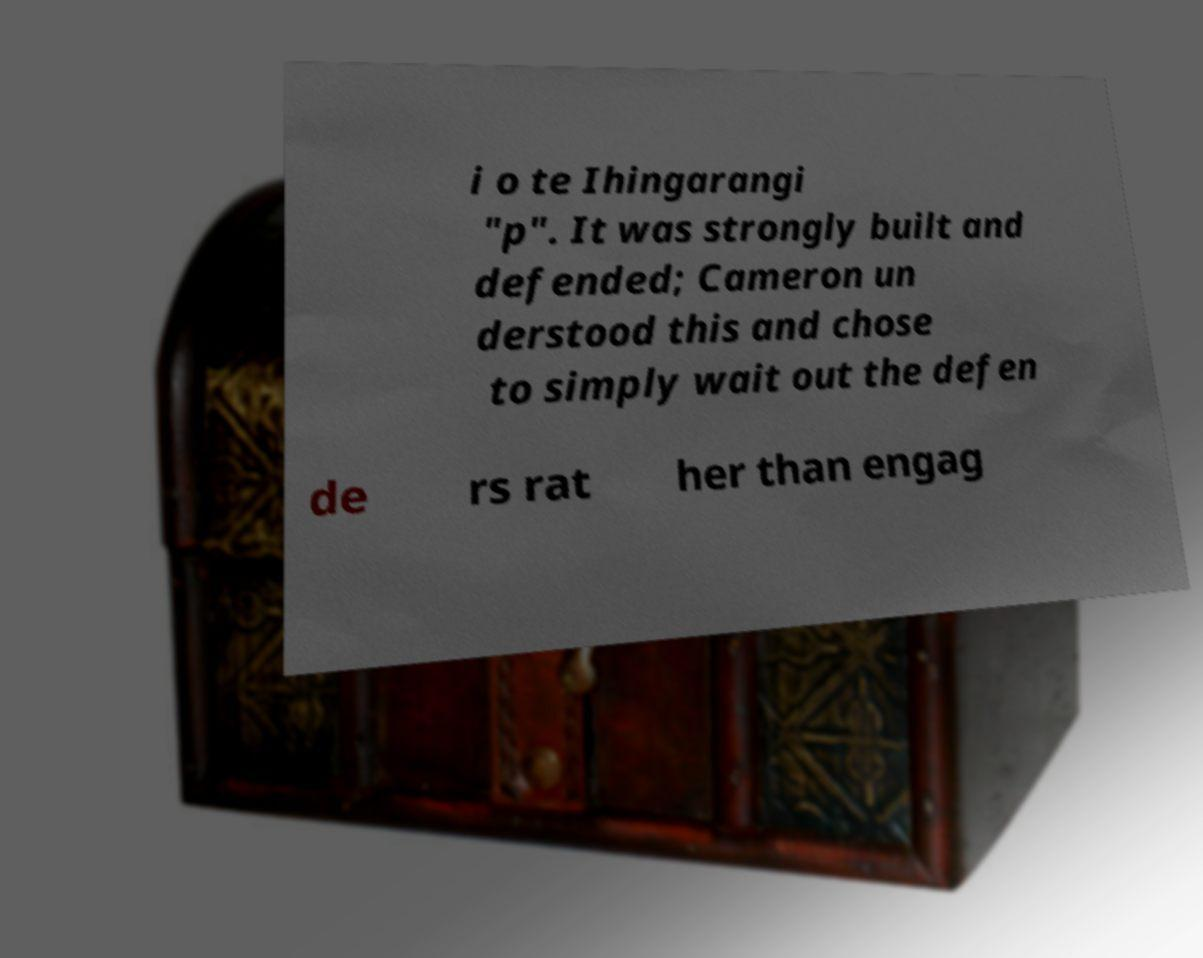There's text embedded in this image that I need extracted. Can you transcribe it verbatim? i o te Ihingarangi "p". It was strongly built and defended; Cameron un derstood this and chose to simply wait out the defen de rs rat her than engag 